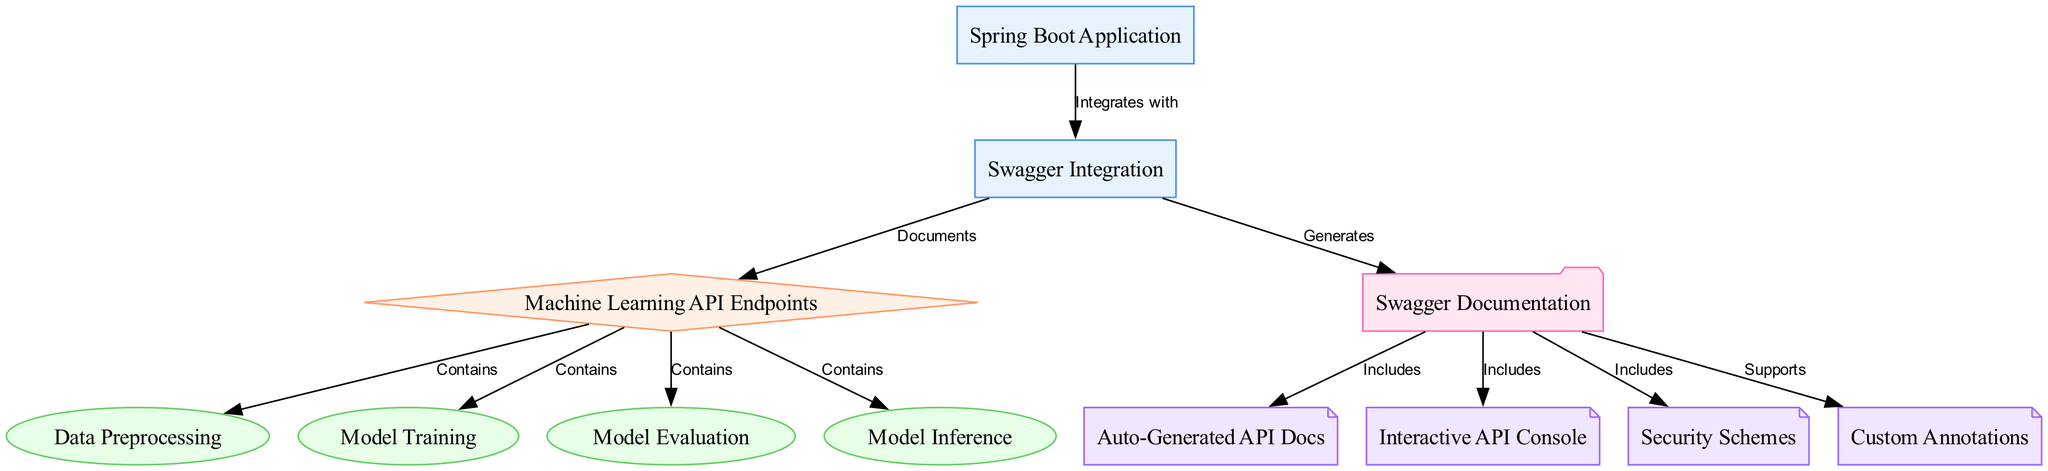What component integrates with Swagger? The diagram shows an edge labeled "Integrates with" between the "Spring Boot Application" node and the "Swagger Integration" node, indicating that the Spring Boot application is the component that integrates with Swagger.
Answer: Spring Boot Application How many types of endpoints are listed in the diagram? The diagram contains four endpoints: Data Preprocessing, Model Training, Model Evaluation, and Model Inference. Therefore, the total number of endpoint types is four.
Answer: 4 What does Swagger generate for the Machine Learning API Endpoints? The diagram indicates an edge labeled "Generates" from "Swagger Integration" to "Swagger Documentation," indicating that Swagger generates the documentation for the Machine Learning API Endpoints.
Answer: Swagger Documentation Which feature is included in the Swagger Documentation? The diagram indicates multiple edges from "Swagger Documentation" that denote different features, including "Auto-Generated API Docs." This indicates that it is one of the features included within the documentation.
Answer: Auto-Generated API Docs Which endpoint is directly associated with the category 'Machine Learning API Endpoints'? According to the diagram, there are multiple endpoints connected to the "Machine Learning API Endpoints," but each of them, including "Data Preprocessing," "Model Training," "Model Evaluation," and "Model Inference," connect through edges labeled "Contains." Therefore, any of these endpoints can be directly associated.
Answer: Data Preprocessing 